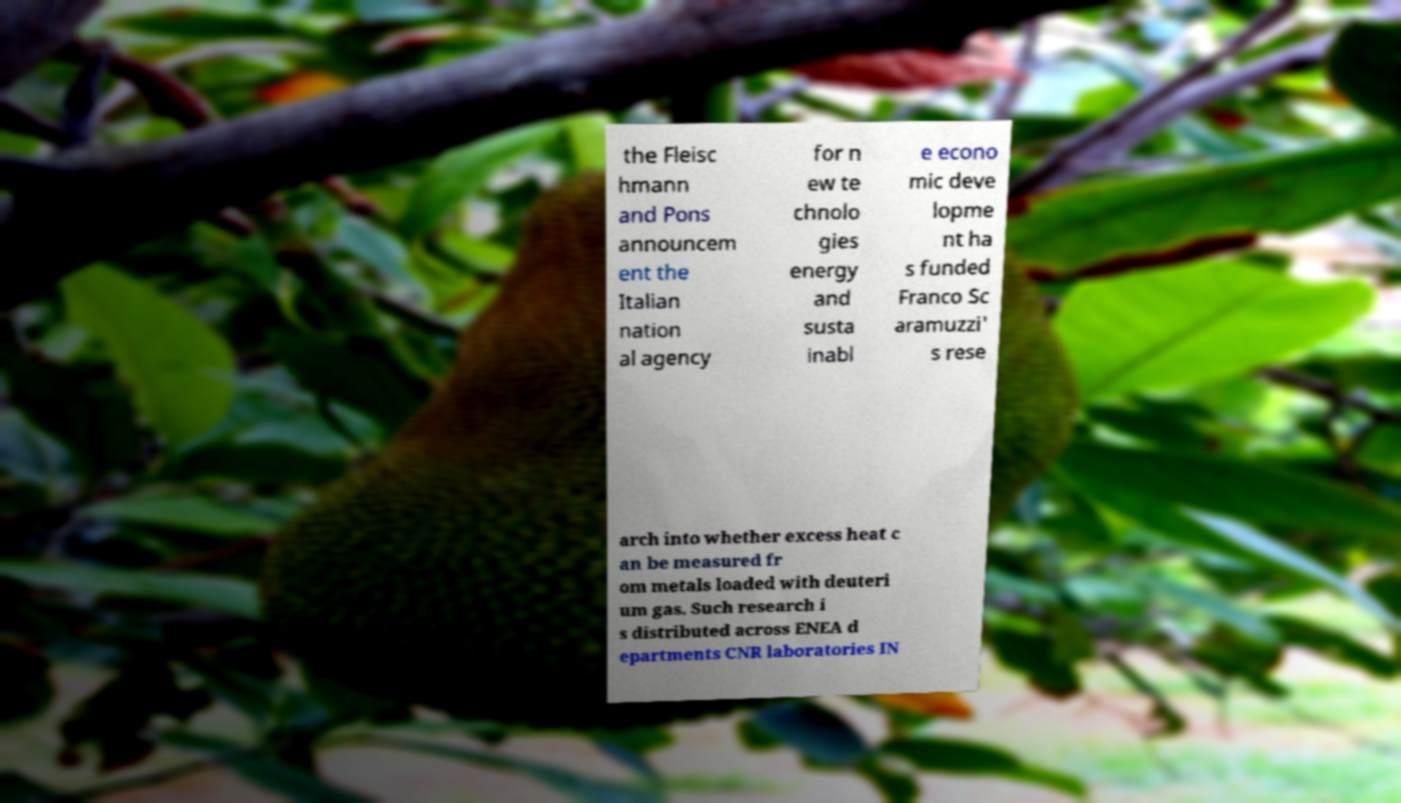Could you assist in decoding the text presented in this image and type it out clearly? the Fleisc hmann and Pons announcem ent the Italian nation al agency for n ew te chnolo gies energy and susta inabl e econo mic deve lopme nt ha s funded Franco Sc aramuzzi' s rese arch into whether excess heat c an be measured fr om metals loaded with deuteri um gas. Such research i s distributed across ENEA d epartments CNR laboratories IN 